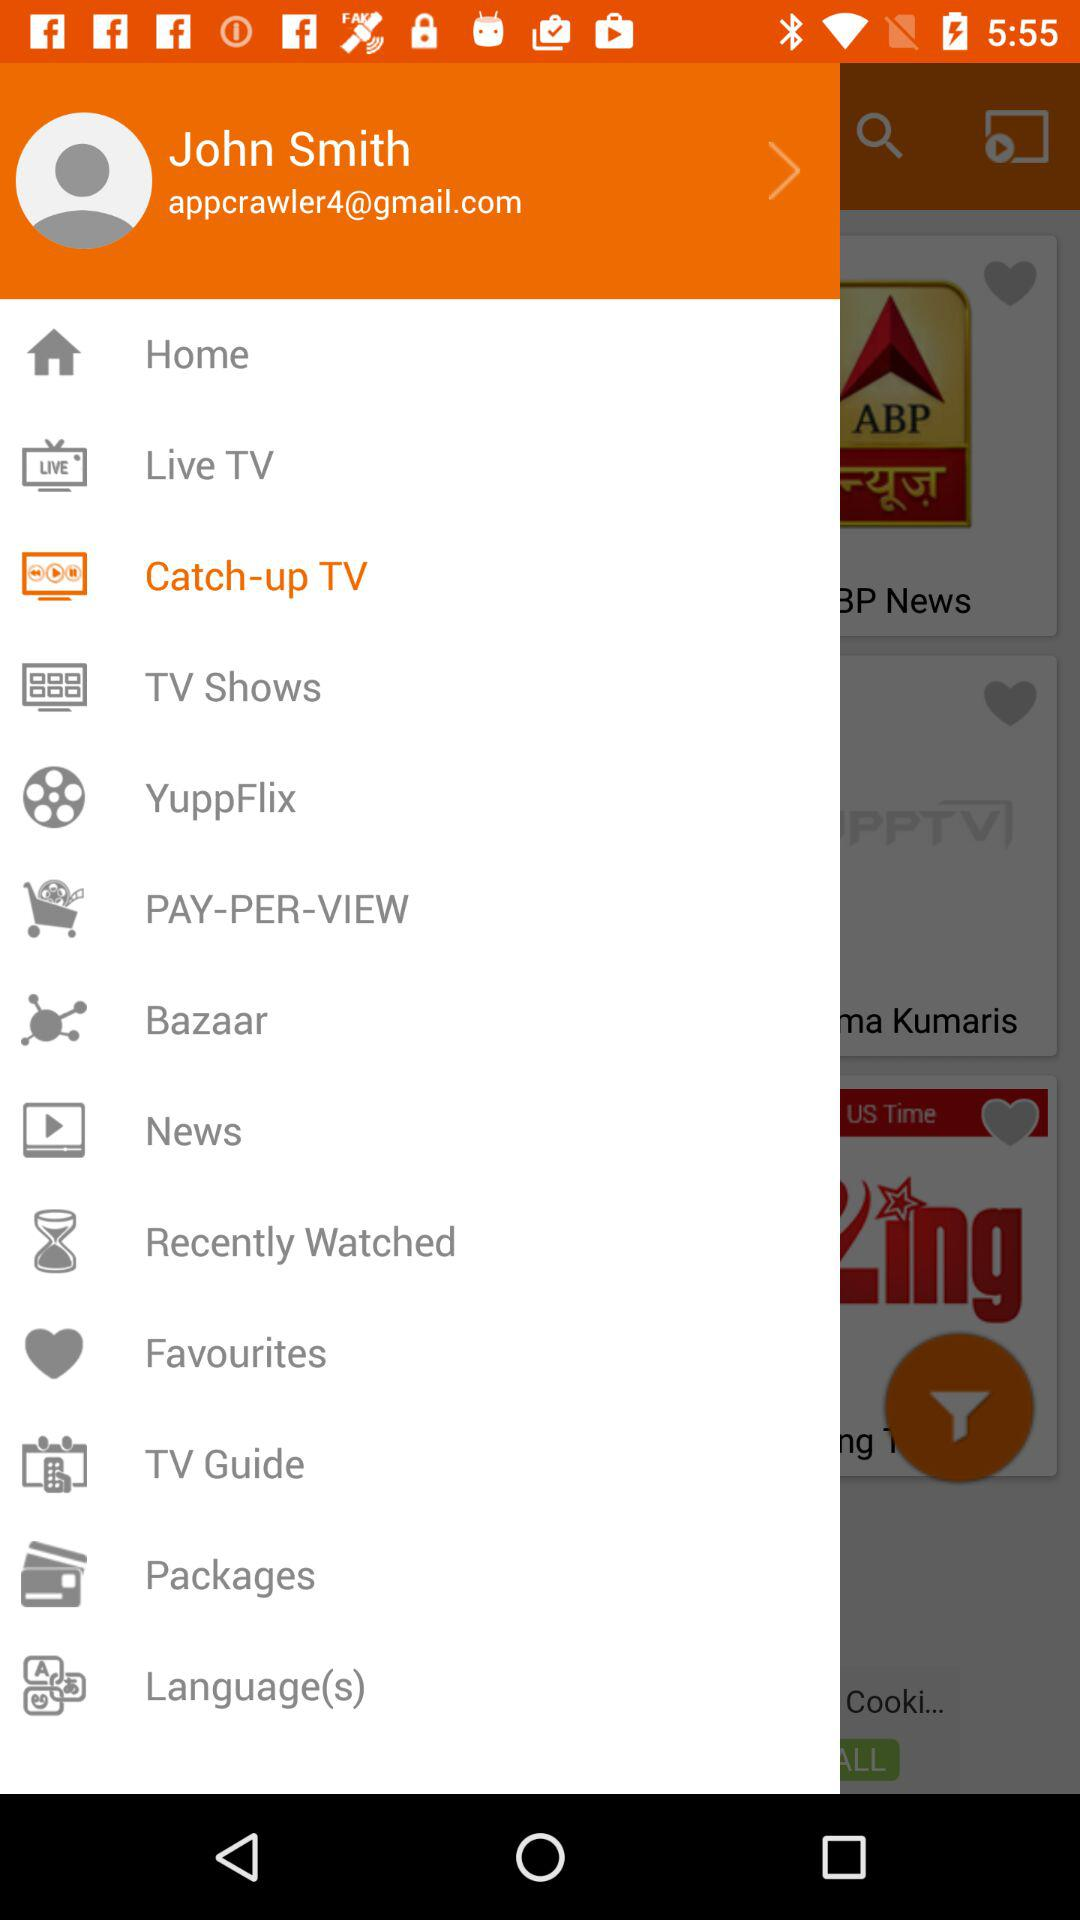What is the email address? The email address is appcrawler4@gmail.com. 